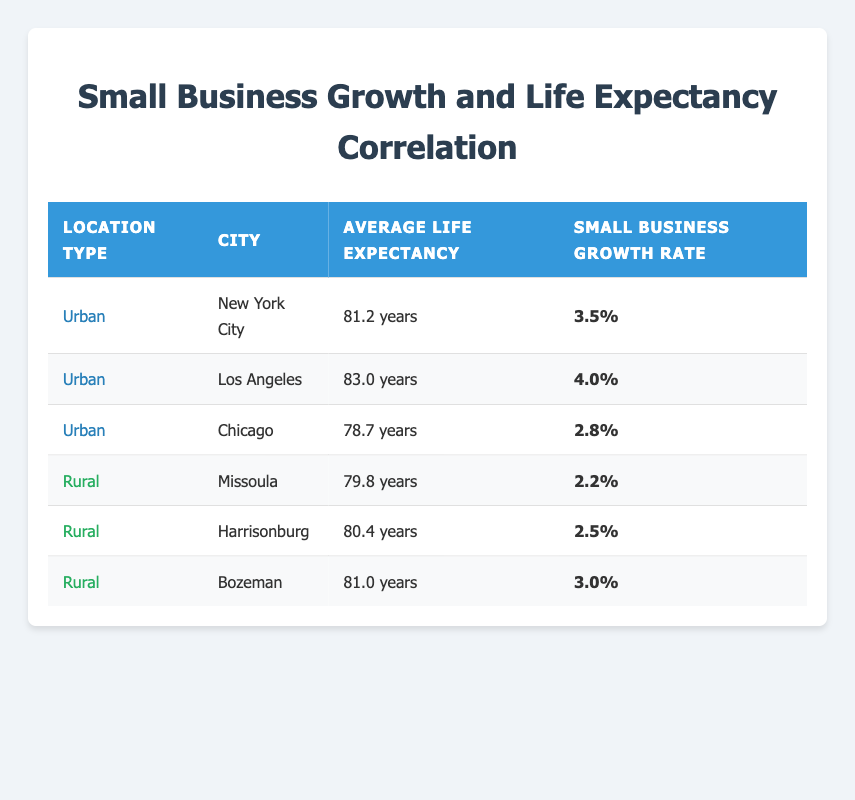What is the average life expectancy of urban locations listed? The table shows the average life expectancy for three urban locations: New York City (81.2), Los Angeles (83.0), and Chicago (78.7). To find the average, we sum these values: 81.2 + 83.0 + 78.7 = 242.9. We then divide by the number of urban locations, which is 3: 242.9 / 3 = 80.9667. Rounding this gives us approximately 81.0 years.
Answer: 81.0 years Which city has the highest small business growth rate? By examining the small business growth rates in the table, we see the rates for the cities: New York City (3.5%), Los Angeles (4.0%), Chicago (2.8%), Missoula (2.2%), Harrisonburg (2.5%), and Bozeman (3.0%). The highest rate is in Los Angeles at 4.0%.
Answer: Los Angeles Is there a correlation between small business growth rates and average life expectancy in urban areas? We can analyze the urban areas' data: New York City (81.2 years, 3.5%), Los Angeles (83.0 years, 4.0%), and Chicago (78.7 years, 2.8%). As life expectancy increases, the small business growth rate also increases. However, a solid correlation assessment requires further statistical analysis. For basic observation, there seems to be a positive tendency, but it's not definitive.
Answer: Yes, there appears to be a positive tendency What is the total small business growth rate for rural areas? From the table, the small business growth rates for the rural areas are: Missoula (2.2%), Harrisonburg (2.5%), and Bozeman (3.0%). To find the total, we add these values: 2.2 + 2.5 + 3.0 = 7.7%.
Answer: 7.7% What is the difference in average life expectancy between urban and rural areas? To find this difference, we first average the life expectancy in urban areas: (81.2 + 83.0 + 78.7) / 3 = 81.0 years. Next, we average the life expectancy for rural areas: (79.8 + 80.4 + 81.0) / 3 = 80.4 years. The difference is 81.0 - 80.4 = 0.6 years.
Answer: 0.6 years Is the average life expectancy in rural areas higher than 80 years? From the calculated average for rural areas, the life expectancies are: Missoula (79.8), Harrisonburg (80.4), and Bozeman (81.0). When averaged, we find it to be approximately 80.4 years. Hence, since 80.4 is greater than 80, the statement is true.
Answer: Yes, it is 